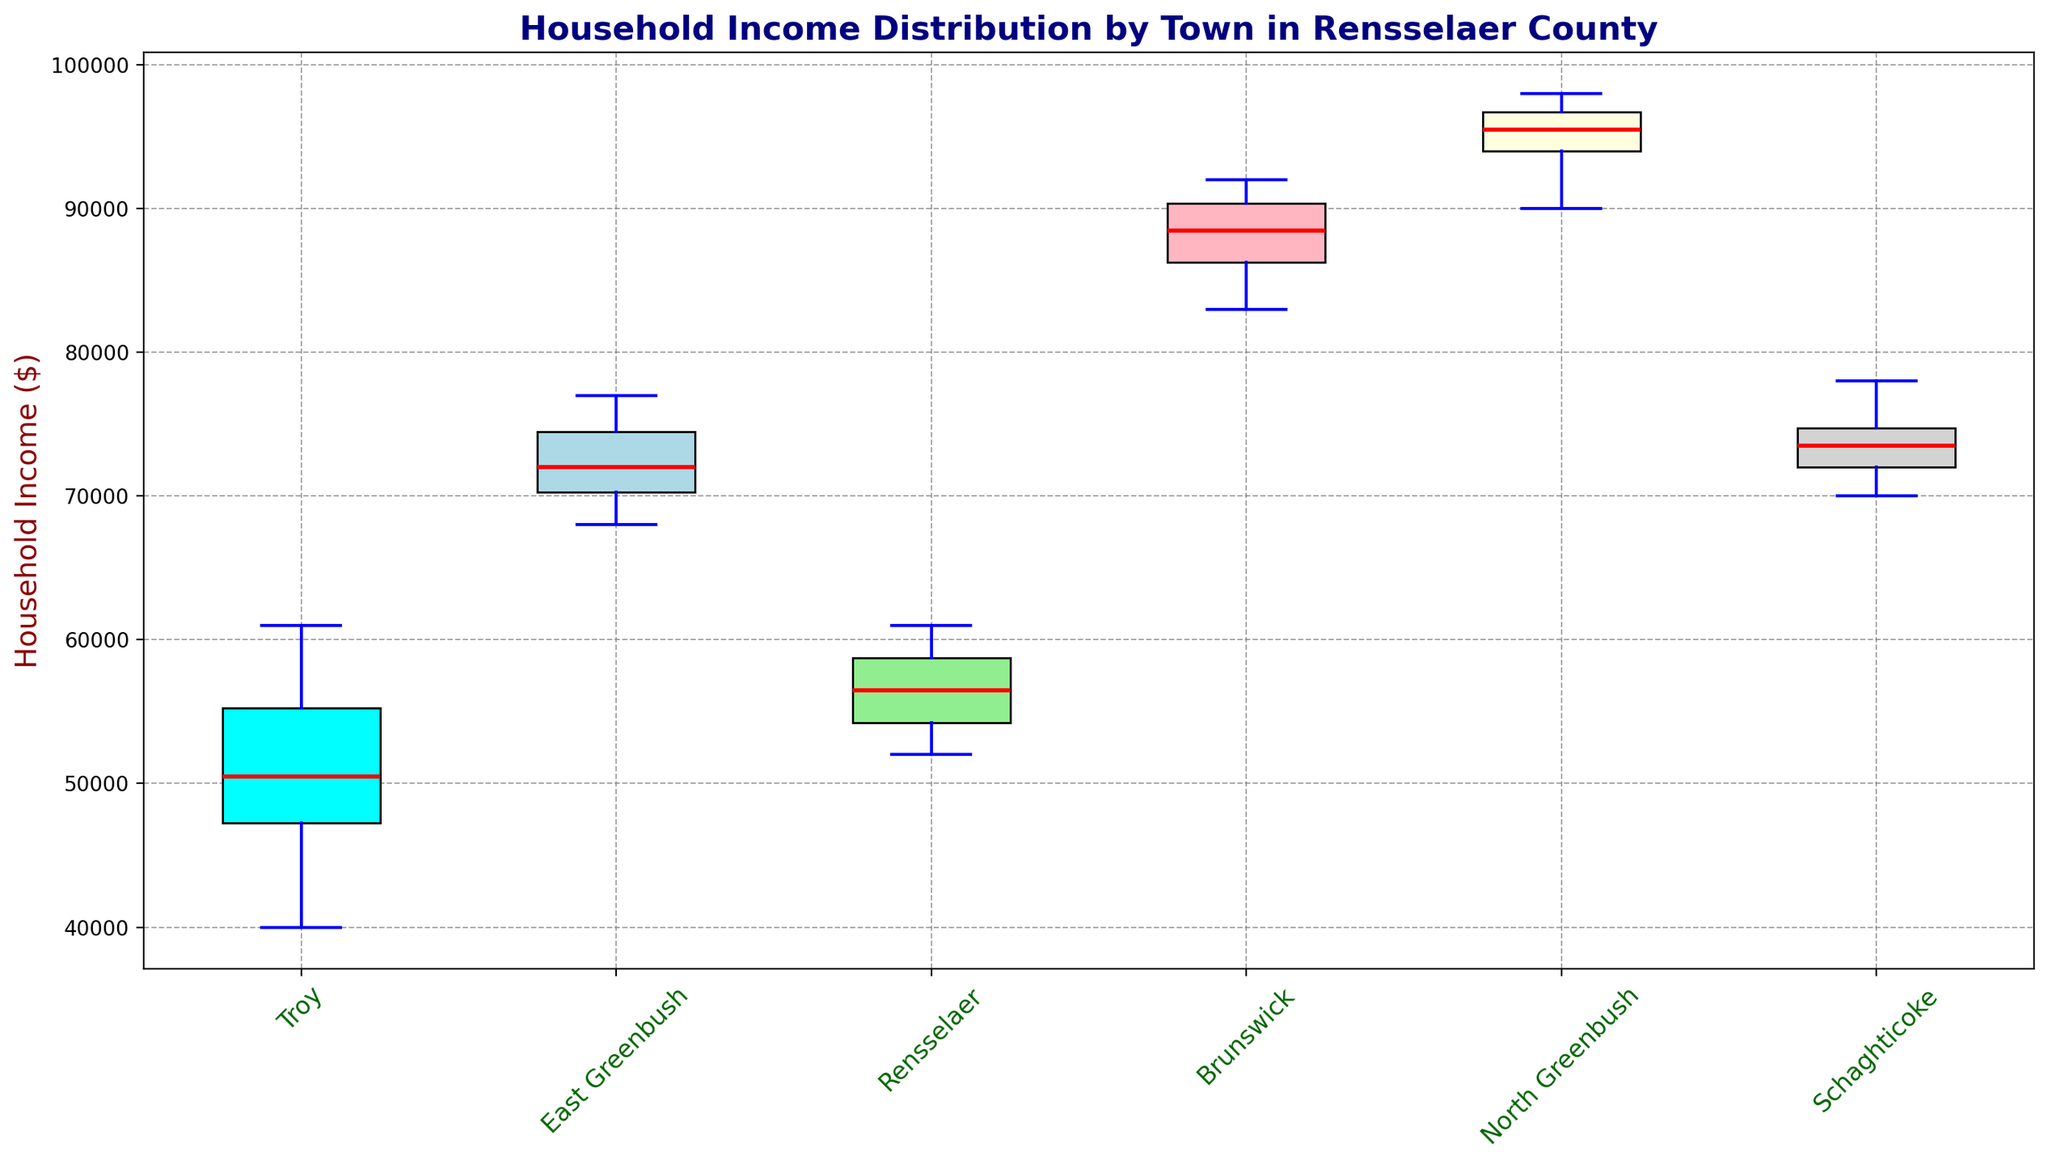Which town has the highest median household income? Look for the position of the median line in each box plot and identify the town where this line is the highest.
Answer: North Greenbush Which town has the lowest median household income? Identify the town where the median line is the lowest among all box plots.
Answer: Troy What is the approximate range of household incomes in Brunswick? The range can be found by subtracting the minimum value (bottom whisker) from the maximum value (top whisker) in the box plot for Brunswick.
Answer: About 9,000 Which town has a wider range of household incomes, Rensselaer or Schaghticoke? Compare the lengths of the whiskers (the lines extending from the boxes) for both towns. The town with the longer whiskers has the wider range.
Answer: Rensselaer How do the median household incomes in Troy and East Greenbush compare? Compare the height of the median lines in the box plots for Troy and East Greenbush.
Answer: East Greenbush > Troy Which town has the most consistent household income distribution based on the interquartile range (IQR)? The IQR is visually represented by the length of the box. The town with the shortest box has the most consistent distribution.
Answer: North Greenbush In which town is the top 25% of households closer in income to the median than in Troy? Look for the distance between the median line and the top of the box. If it is shorter than in Troy, the top 25% is closer in income to the median.
Answer: Rensselaer Are there any outliers in the household incomes of East Greenbush? Outliers are typically shown as dots outside the whiskers in a box plot. Check East Greenbush's plot for the presence of such dots.
Answer: No Which towns have similar median household incomes? Compare the heights of the median lines across different box plots and identify towns where the medians are at similar levels.
Answer: East Greenbush and Schaghticoke How does the upper whisker of Brunswick compare to that of North Greenbush? Observe the lengths of the upper whiskers (lines extending from the top of the boxes) for Brunswick and North Greenbush.
Answer: Brunswick < North Greenbush 